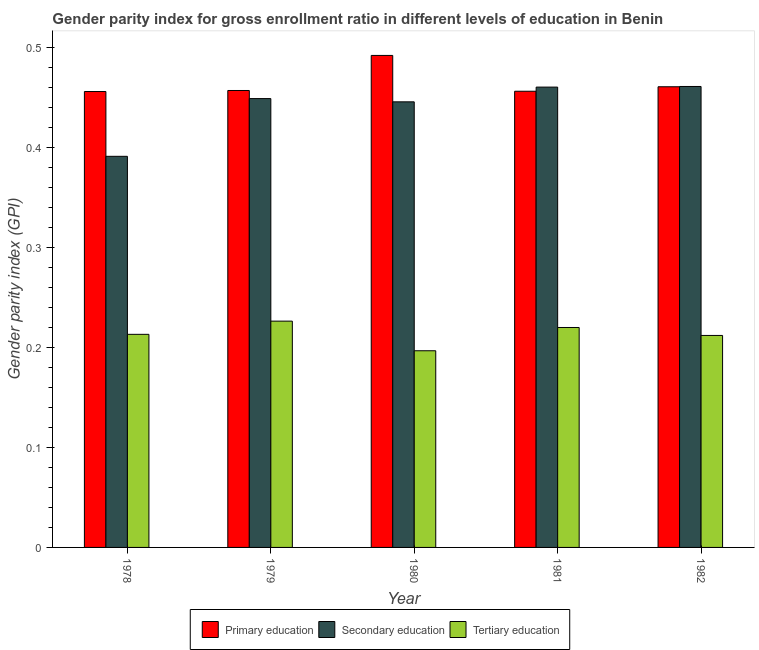How many different coloured bars are there?
Your answer should be very brief. 3. How many bars are there on the 1st tick from the left?
Give a very brief answer. 3. What is the gender parity index in secondary education in 1978?
Give a very brief answer. 0.39. Across all years, what is the maximum gender parity index in tertiary education?
Give a very brief answer. 0.23. Across all years, what is the minimum gender parity index in tertiary education?
Keep it short and to the point. 0.2. In which year was the gender parity index in tertiary education maximum?
Your answer should be very brief. 1979. In which year was the gender parity index in tertiary education minimum?
Make the answer very short. 1980. What is the total gender parity index in secondary education in the graph?
Provide a short and direct response. 2.21. What is the difference between the gender parity index in secondary education in 1978 and that in 1981?
Your answer should be very brief. -0.07. What is the difference between the gender parity index in tertiary education in 1978 and the gender parity index in secondary education in 1981?
Keep it short and to the point. -0.01. What is the average gender parity index in secondary education per year?
Your response must be concise. 0.44. In the year 1981, what is the difference between the gender parity index in secondary education and gender parity index in primary education?
Give a very brief answer. 0. What is the ratio of the gender parity index in secondary education in 1980 to that in 1981?
Your answer should be very brief. 0.97. Is the gender parity index in primary education in 1978 less than that in 1982?
Your answer should be very brief. Yes. Is the difference between the gender parity index in tertiary education in 1980 and 1982 greater than the difference between the gender parity index in secondary education in 1980 and 1982?
Offer a very short reply. No. What is the difference between the highest and the second highest gender parity index in tertiary education?
Ensure brevity in your answer.  0.01. What is the difference between the highest and the lowest gender parity index in secondary education?
Offer a terse response. 0.07. In how many years, is the gender parity index in primary education greater than the average gender parity index in primary education taken over all years?
Offer a terse response. 1. Is the sum of the gender parity index in secondary education in 1978 and 1980 greater than the maximum gender parity index in primary education across all years?
Provide a succinct answer. Yes. What does the 1st bar from the right in 1980 represents?
Your answer should be compact. Tertiary education. What is the difference between two consecutive major ticks on the Y-axis?
Keep it short and to the point. 0.1. Are the values on the major ticks of Y-axis written in scientific E-notation?
Keep it short and to the point. No. Does the graph contain any zero values?
Give a very brief answer. No. Does the graph contain grids?
Ensure brevity in your answer.  No. How are the legend labels stacked?
Offer a terse response. Horizontal. What is the title of the graph?
Your answer should be compact. Gender parity index for gross enrollment ratio in different levels of education in Benin. What is the label or title of the Y-axis?
Make the answer very short. Gender parity index (GPI). What is the Gender parity index (GPI) in Primary education in 1978?
Keep it short and to the point. 0.46. What is the Gender parity index (GPI) in Secondary education in 1978?
Offer a very short reply. 0.39. What is the Gender parity index (GPI) in Tertiary education in 1978?
Ensure brevity in your answer.  0.21. What is the Gender parity index (GPI) in Primary education in 1979?
Your response must be concise. 0.46. What is the Gender parity index (GPI) of Secondary education in 1979?
Your answer should be very brief. 0.45. What is the Gender parity index (GPI) in Tertiary education in 1979?
Make the answer very short. 0.23. What is the Gender parity index (GPI) of Primary education in 1980?
Your answer should be compact. 0.49. What is the Gender parity index (GPI) in Secondary education in 1980?
Offer a terse response. 0.45. What is the Gender parity index (GPI) in Tertiary education in 1980?
Your answer should be compact. 0.2. What is the Gender parity index (GPI) in Primary education in 1981?
Provide a succinct answer. 0.46. What is the Gender parity index (GPI) in Secondary education in 1981?
Make the answer very short. 0.46. What is the Gender parity index (GPI) in Tertiary education in 1981?
Give a very brief answer. 0.22. What is the Gender parity index (GPI) of Primary education in 1982?
Provide a short and direct response. 0.46. What is the Gender parity index (GPI) of Secondary education in 1982?
Offer a terse response. 0.46. What is the Gender parity index (GPI) in Tertiary education in 1982?
Provide a short and direct response. 0.21. Across all years, what is the maximum Gender parity index (GPI) in Primary education?
Offer a very short reply. 0.49. Across all years, what is the maximum Gender parity index (GPI) of Secondary education?
Provide a succinct answer. 0.46. Across all years, what is the maximum Gender parity index (GPI) of Tertiary education?
Your answer should be compact. 0.23. Across all years, what is the minimum Gender parity index (GPI) of Primary education?
Offer a terse response. 0.46. Across all years, what is the minimum Gender parity index (GPI) of Secondary education?
Your answer should be very brief. 0.39. Across all years, what is the minimum Gender parity index (GPI) in Tertiary education?
Your answer should be compact. 0.2. What is the total Gender parity index (GPI) in Primary education in the graph?
Keep it short and to the point. 2.32. What is the total Gender parity index (GPI) in Secondary education in the graph?
Provide a short and direct response. 2.21. What is the total Gender parity index (GPI) of Tertiary education in the graph?
Provide a succinct answer. 1.07. What is the difference between the Gender parity index (GPI) of Primary education in 1978 and that in 1979?
Your response must be concise. -0. What is the difference between the Gender parity index (GPI) in Secondary education in 1978 and that in 1979?
Your answer should be compact. -0.06. What is the difference between the Gender parity index (GPI) in Tertiary education in 1978 and that in 1979?
Provide a short and direct response. -0.01. What is the difference between the Gender parity index (GPI) of Primary education in 1978 and that in 1980?
Your answer should be very brief. -0.04. What is the difference between the Gender parity index (GPI) in Secondary education in 1978 and that in 1980?
Make the answer very short. -0.05. What is the difference between the Gender parity index (GPI) in Tertiary education in 1978 and that in 1980?
Make the answer very short. 0.02. What is the difference between the Gender parity index (GPI) of Primary education in 1978 and that in 1981?
Make the answer very short. -0. What is the difference between the Gender parity index (GPI) of Secondary education in 1978 and that in 1981?
Give a very brief answer. -0.07. What is the difference between the Gender parity index (GPI) of Tertiary education in 1978 and that in 1981?
Offer a very short reply. -0.01. What is the difference between the Gender parity index (GPI) of Primary education in 1978 and that in 1982?
Provide a short and direct response. -0. What is the difference between the Gender parity index (GPI) in Secondary education in 1978 and that in 1982?
Your answer should be very brief. -0.07. What is the difference between the Gender parity index (GPI) in Tertiary education in 1978 and that in 1982?
Your answer should be compact. 0. What is the difference between the Gender parity index (GPI) of Primary education in 1979 and that in 1980?
Your response must be concise. -0.04. What is the difference between the Gender parity index (GPI) in Secondary education in 1979 and that in 1980?
Provide a short and direct response. 0. What is the difference between the Gender parity index (GPI) of Tertiary education in 1979 and that in 1980?
Your answer should be compact. 0.03. What is the difference between the Gender parity index (GPI) in Primary education in 1979 and that in 1981?
Ensure brevity in your answer.  0. What is the difference between the Gender parity index (GPI) of Secondary education in 1979 and that in 1981?
Make the answer very short. -0.01. What is the difference between the Gender parity index (GPI) in Tertiary education in 1979 and that in 1981?
Ensure brevity in your answer.  0.01. What is the difference between the Gender parity index (GPI) in Primary education in 1979 and that in 1982?
Offer a terse response. -0. What is the difference between the Gender parity index (GPI) of Secondary education in 1979 and that in 1982?
Offer a terse response. -0.01. What is the difference between the Gender parity index (GPI) in Tertiary education in 1979 and that in 1982?
Provide a succinct answer. 0.01. What is the difference between the Gender parity index (GPI) in Primary education in 1980 and that in 1981?
Offer a terse response. 0.04. What is the difference between the Gender parity index (GPI) of Secondary education in 1980 and that in 1981?
Your answer should be compact. -0.01. What is the difference between the Gender parity index (GPI) of Tertiary education in 1980 and that in 1981?
Your response must be concise. -0.02. What is the difference between the Gender parity index (GPI) of Primary education in 1980 and that in 1982?
Give a very brief answer. 0.03. What is the difference between the Gender parity index (GPI) in Secondary education in 1980 and that in 1982?
Keep it short and to the point. -0.02. What is the difference between the Gender parity index (GPI) of Tertiary education in 1980 and that in 1982?
Offer a terse response. -0.02. What is the difference between the Gender parity index (GPI) in Primary education in 1981 and that in 1982?
Ensure brevity in your answer.  -0. What is the difference between the Gender parity index (GPI) of Secondary education in 1981 and that in 1982?
Offer a very short reply. -0. What is the difference between the Gender parity index (GPI) in Tertiary education in 1981 and that in 1982?
Provide a short and direct response. 0.01. What is the difference between the Gender parity index (GPI) of Primary education in 1978 and the Gender parity index (GPI) of Secondary education in 1979?
Give a very brief answer. 0.01. What is the difference between the Gender parity index (GPI) in Primary education in 1978 and the Gender parity index (GPI) in Tertiary education in 1979?
Give a very brief answer. 0.23. What is the difference between the Gender parity index (GPI) of Secondary education in 1978 and the Gender parity index (GPI) of Tertiary education in 1979?
Your answer should be very brief. 0.16. What is the difference between the Gender parity index (GPI) of Primary education in 1978 and the Gender parity index (GPI) of Secondary education in 1980?
Give a very brief answer. 0.01. What is the difference between the Gender parity index (GPI) in Primary education in 1978 and the Gender parity index (GPI) in Tertiary education in 1980?
Your response must be concise. 0.26. What is the difference between the Gender parity index (GPI) of Secondary education in 1978 and the Gender parity index (GPI) of Tertiary education in 1980?
Offer a terse response. 0.19. What is the difference between the Gender parity index (GPI) in Primary education in 1978 and the Gender parity index (GPI) in Secondary education in 1981?
Ensure brevity in your answer.  -0. What is the difference between the Gender parity index (GPI) of Primary education in 1978 and the Gender parity index (GPI) of Tertiary education in 1981?
Your answer should be very brief. 0.24. What is the difference between the Gender parity index (GPI) in Secondary education in 1978 and the Gender parity index (GPI) in Tertiary education in 1981?
Your answer should be very brief. 0.17. What is the difference between the Gender parity index (GPI) of Primary education in 1978 and the Gender parity index (GPI) of Secondary education in 1982?
Offer a very short reply. -0.01. What is the difference between the Gender parity index (GPI) in Primary education in 1978 and the Gender parity index (GPI) in Tertiary education in 1982?
Offer a very short reply. 0.24. What is the difference between the Gender parity index (GPI) of Secondary education in 1978 and the Gender parity index (GPI) of Tertiary education in 1982?
Make the answer very short. 0.18. What is the difference between the Gender parity index (GPI) of Primary education in 1979 and the Gender parity index (GPI) of Secondary education in 1980?
Provide a succinct answer. 0.01. What is the difference between the Gender parity index (GPI) of Primary education in 1979 and the Gender parity index (GPI) of Tertiary education in 1980?
Give a very brief answer. 0.26. What is the difference between the Gender parity index (GPI) of Secondary education in 1979 and the Gender parity index (GPI) of Tertiary education in 1980?
Your answer should be very brief. 0.25. What is the difference between the Gender parity index (GPI) in Primary education in 1979 and the Gender parity index (GPI) in Secondary education in 1981?
Make the answer very short. -0. What is the difference between the Gender parity index (GPI) in Primary education in 1979 and the Gender parity index (GPI) in Tertiary education in 1981?
Provide a succinct answer. 0.24. What is the difference between the Gender parity index (GPI) in Secondary education in 1979 and the Gender parity index (GPI) in Tertiary education in 1981?
Your answer should be compact. 0.23. What is the difference between the Gender parity index (GPI) of Primary education in 1979 and the Gender parity index (GPI) of Secondary education in 1982?
Keep it short and to the point. -0. What is the difference between the Gender parity index (GPI) of Primary education in 1979 and the Gender parity index (GPI) of Tertiary education in 1982?
Provide a succinct answer. 0.24. What is the difference between the Gender parity index (GPI) in Secondary education in 1979 and the Gender parity index (GPI) in Tertiary education in 1982?
Ensure brevity in your answer.  0.24. What is the difference between the Gender parity index (GPI) of Primary education in 1980 and the Gender parity index (GPI) of Secondary education in 1981?
Offer a very short reply. 0.03. What is the difference between the Gender parity index (GPI) in Primary education in 1980 and the Gender parity index (GPI) in Tertiary education in 1981?
Your answer should be compact. 0.27. What is the difference between the Gender parity index (GPI) of Secondary education in 1980 and the Gender parity index (GPI) of Tertiary education in 1981?
Your answer should be very brief. 0.23. What is the difference between the Gender parity index (GPI) of Primary education in 1980 and the Gender parity index (GPI) of Secondary education in 1982?
Keep it short and to the point. 0.03. What is the difference between the Gender parity index (GPI) in Primary education in 1980 and the Gender parity index (GPI) in Tertiary education in 1982?
Offer a terse response. 0.28. What is the difference between the Gender parity index (GPI) in Secondary education in 1980 and the Gender parity index (GPI) in Tertiary education in 1982?
Give a very brief answer. 0.23. What is the difference between the Gender parity index (GPI) of Primary education in 1981 and the Gender parity index (GPI) of Secondary education in 1982?
Your response must be concise. -0. What is the difference between the Gender parity index (GPI) in Primary education in 1981 and the Gender parity index (GPI) in Tertiary education in 1982?
Offer a terse response. 0.24. What is the difference between the Gender parity index (GPI) in Secondary education in 1981 and the Gender parity index (GPI) in Tertiary education in 1982?
Your answer should be very brief. 0.25. What is the average Gender parity index (GPI) in Primary education per year?
Offer a terse response. 0.46. What is the average Gender parity index (GPI) of Secondary education per year?
Keep it short and to the point. 0.44. What is the average Gender parity index (GPI) in Tertiary education per year?
Give a very brief answer. 0.21. In the year 1978, what is the difference between the Gender parity index (GPI) in Primary education and Gender parity index (GPI) in Secondary education?
Your answer should be compact. 0.06. In the year 1978, what is the difference between the Gender parity index (GPI) of Primary education and Gender parity index (GPI) of Tertiary education?
Offer a very short reply. 0.24. In the year 1978, what is the difference between the Gender parity index (GPI) in Secondary education and Gender parity index (GPI) in Tertiary education?
Make the answer very short. 0.18. In the year 1979, what is the difference between the Gender parity index (GPI) of Primary education and Gender parity index (GPI) of Secondary education?
Provide a succinct answer. 0.01. In the year 1979, what is the difference between the Gender parity index (GPI) of Primary education and Gender parity index (GPI) of Tertiary education?
Your answer should be very brief. 0.23. In the year 1979, what is the difference between the Gender parity index (GPI) in Secondary education and Gender parity index (GPI) in Tertiary education?
Ensure brevity in your answer.  0.22. In the year 1980, what is the difference between the Gender parity index (GPI) of Primary education and Gender parity index (GPI) of Secondary education?
Ensure brevity in your answer.  0.05. In the year 1980, what is the difference between the Gender parity index (GPI) of Primary education and Gender parity index (GPI) of Tertiary education?
Your answer should be very brief. 0.3. In the year 1980, what is the difference between the Gender parity index (GPI) of Secondary education and Gender parity index (GPI) of Tertiary education?
Offer a very short reply. 0.25. In the year 1981, what is the difference between the Gender parity index (GPI) in Primary education and Gender parity index (GPI) in Secondary education?
Your answer should be very brief. -0. In the year 1981, what is the difference between the Gender parity index (GPI) in Primary education and Gender parity index (GPI) in Tertiary education?
Your answer should be compact. 0.24. In the year 1981, what is the difference between the Gender parity index (GPI) of Secondary education and Gender parity index (GPI) of Tertiary education?
Provide a short and direct response. 0.24. In the year 1982, what is the difference between the Gender parity index (GPI) in Primary education and Gender parity index (GPI) in Secondary education?
Your answer should be compact. -0. In the year 1982, what is the difference between the Gender parity index (GPI) in Primary education and Gender parity index (GPI) in Tertiary education?
Ensure brevity in your answer.  0.25. In the year 1982, what is the difference between the Gender parity index (GPI) of Secondary education and Gender parity index (GPI) of Tertiary education?
Provide a short and direct response. 0.25. What is the ratio of the Gender parity index (GPI) of Secondary education in 1978 to that in 1979?
Provide a short and direct response. 0.87. What is the ratio of the Gender parity index (GPI) of Tertiary education in 1978 to that in 1979?
Make the answer very short. 0.94. What is the ratio of the Gender parity index (GPI) in Primary education in 1978 to that in 1980?
Keep it short and to the point. 0.93. What is the ratio of the Gender parity index (GPI) in Secondary education in 1978 to that in 1980?
Keep it short and to the point. 0.88. What is the ratio of the Gender parity index (GPI) in Tertiary education in 1978 to that in 1980?
Offer a terse response. 1.08. What is the ratio of the Gender parity index (GPI) in Secondary education in 1978 to that in 1981?
Offer a very short reply. 0.85. What is the ratio of the Gender parity index (GPI) in Tertiary education in 1978 to that in 1981?
Ensure brevity in your answer.  0.97. What is the ratio of the Gender parity index (GPI) in Secondary education in 1978 to that in 1982?
Make the answer very short. 0.85. What is the ratio of the Gender parity index (GPI) of Tertiary education in 1978 to that in 1982?
Keep it short and to the point. 1.01. What is the ratio of the Gender parity index (GPI) in Primary education in 1979 to that in 1980?
Give a very brief answer. 0.93. What is the ratio of the Gender parity index (GPI) in Secondary education in 1979 to that in 1980?
Ensure brevity in your answer.  1.01. What is the ratio of the Gender parity index (GPI) in Tertiary education in 1979 to that in 1980?
Keep it short and to the point. 1.15. What is the ratio of the Gender parity index (GPI) in Primary education in 1979 to that in 1981?
Your response must be concise. 1. What is the ratio of the Gender parity index (GPI) in Secondary education in 1979 to that in 1981?
Your response must be concise. 0.98. What is the ratio of the Gender parity index (GPI) in Tertiary education in 1979 to that in 1981?
Provide a succinct answer. 1.03. What is the ratio of the Gender parity index (GPI) of Secondary education in 1979 to that in 1982?
Offer a terse response. 0.97. What is the ratio of the Gender parity index (GPI) of Tertiary education in 1979 to that in 1982?
Give a very brief answer. 1.07. What is the ratio of the Gender parity index (GPI) of Primary education in 1980 to that in 1981?
Give a very brief answer. 1.08. What is the ratio of the Gender parity index (GPI) of Secondary education in 1980 to that in 1981?
Offer a terse response. 0.97. What is the ratio of the Gender parity index (GPI) of Tertiary education in 1980 to that in 1981?
Your answer should be compact. 0.89. What is the ratio of the Gender parity index (GPI) of Primary education in 1980 to that in 1982?
Offer a terse response. 1.07. What is the ratio of the Gender parity index (GPI) in Secondary education in 1980 to that in 1982?
Your answer should be very brief. 0.97. What is the ratio of the Gender parity index (GPI) in Tertiary education in 1980 to that in 1982?
Offer a very short reply. 0.93. What is the ratio of the Gender parity index (GPI) of Primary education in 1981 to that in 1982?
Your answer should be compact. 0.99. What is the ratio of the Gender parity index (GPI) of Secondary education in 1981 to that in 1982?
Make the answer very short. 1. What is the ratio of the Gender parity index (GPI) of Tertiary education in 1981 to that in 1982?
Keep it short and to the point. 1.04. What is the difference between the highest and the second highest Gender parity index (GPI) of Primary education?
Provide a short and direct response. 0.03. What is the difference between the highest and the second highest Gender parity index (GPI) of Secondary education?
Offer a terse response. 0. What is the difference between the highest and the second highest Gender parity index (GPI) in Tertiary education?
Your response must be concise. 0.01. What is the difference between the highest and the lowest Gender parity index (GPI) of Primary education?
Offer a very short reply. 0.04. What is the difference between the highest and the lowest Gender parity index (GPI) of Secondary education?
Provide a succinct answer. 0.07. What is the difference between the highest and the lowest Gender parity index (GPI) of Tertiary education?
Provide a succinct answer. 0.03. 